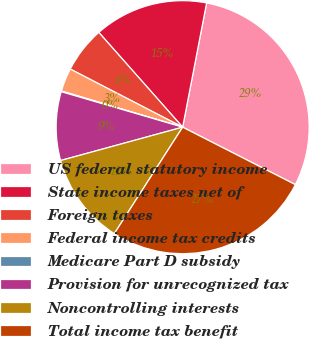Convert chart to OTSL. <chart><loc_0><loc_0><loc_500><loc_500><pie_chart><fcel>US federal statutory income<fcel>State income taxes net of<fcel>Foreign taxes<fcel>Federal income tax credits<fcel>Medicare Part D subsidy<fcel>Provision for unrecognized tax<fcel>Noncontrolling interests<fcel>Total income tax benefit<nl><fcel>29.47%<fcel>14.56%<fcel>5.88%<fcel>2.98%<fcel>0.09%<fcel>8.77%<fcel>11.67%<fcel>26.58%<nl></chart> 